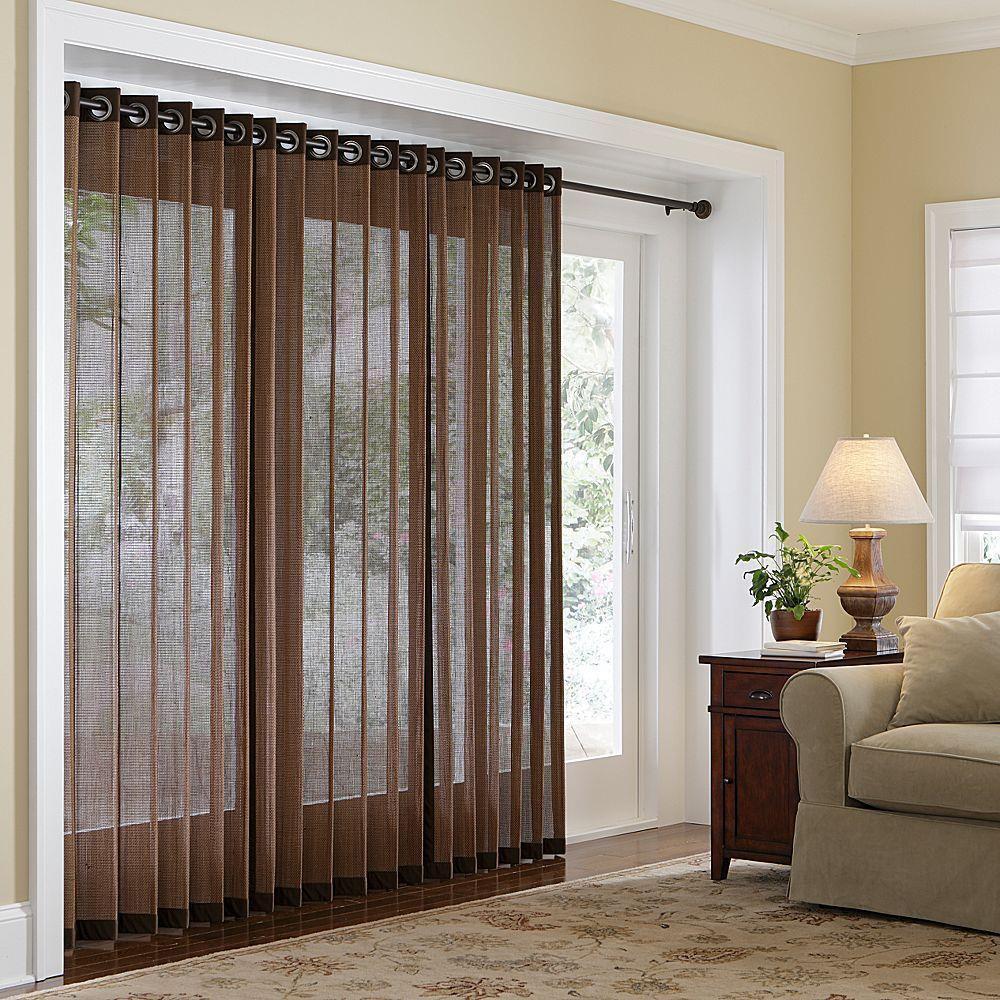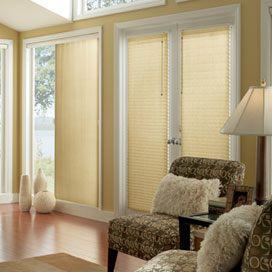The first image is the image on the left, the second image is the image on the right. For the images shown, is this caption "The windows in the left image have drapes." true? Answer yes or no. Yes. 